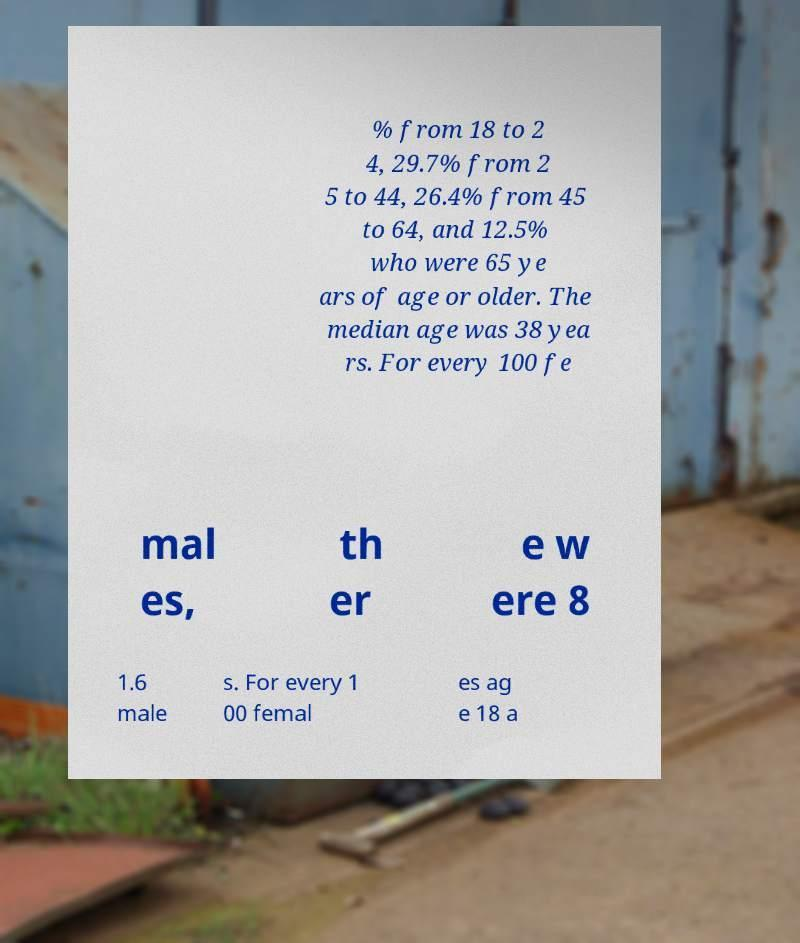Could you assist in decoding the text presented in this image and type it out clearly? % from 18 to 2 4, 29.7% from 2 5 to 44, 26.4% from 45 to 64, and 12.5% who were 65 ye ars of age or older. The median age was 38 yea rs. For every 100 fe mal es, th er e w ere 8 1.6 male s. For every 1 00 femal es ag e 18 a 